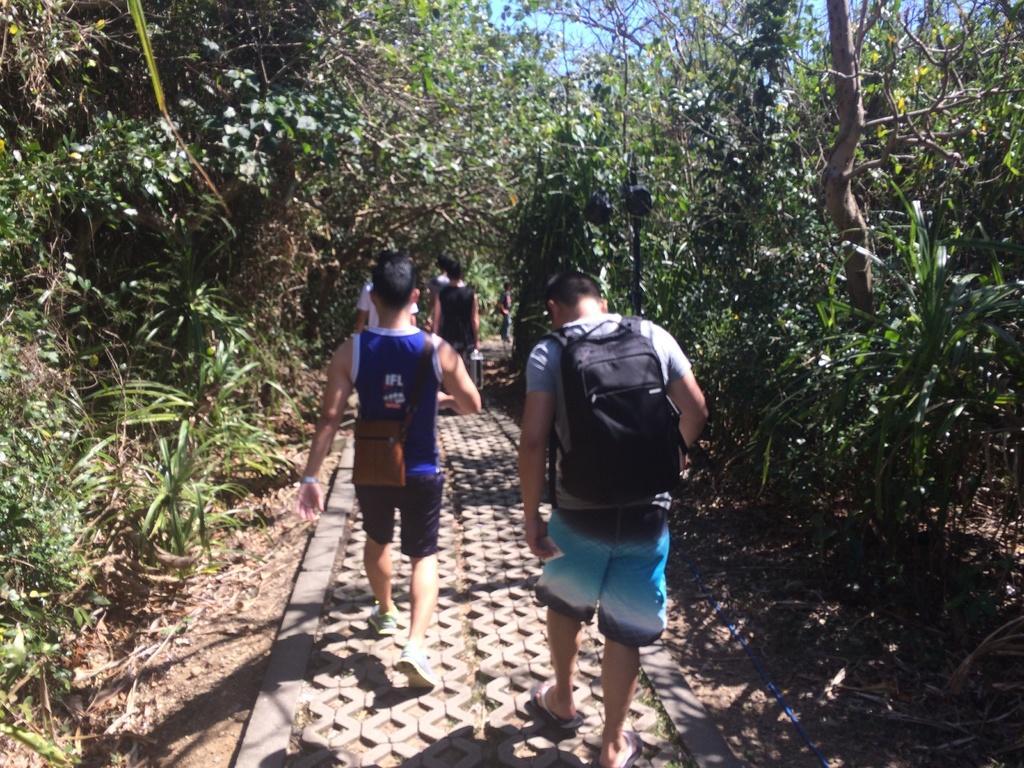Please provide a concise description of this image. These people are walking. Beside these people there are plants and trees. 